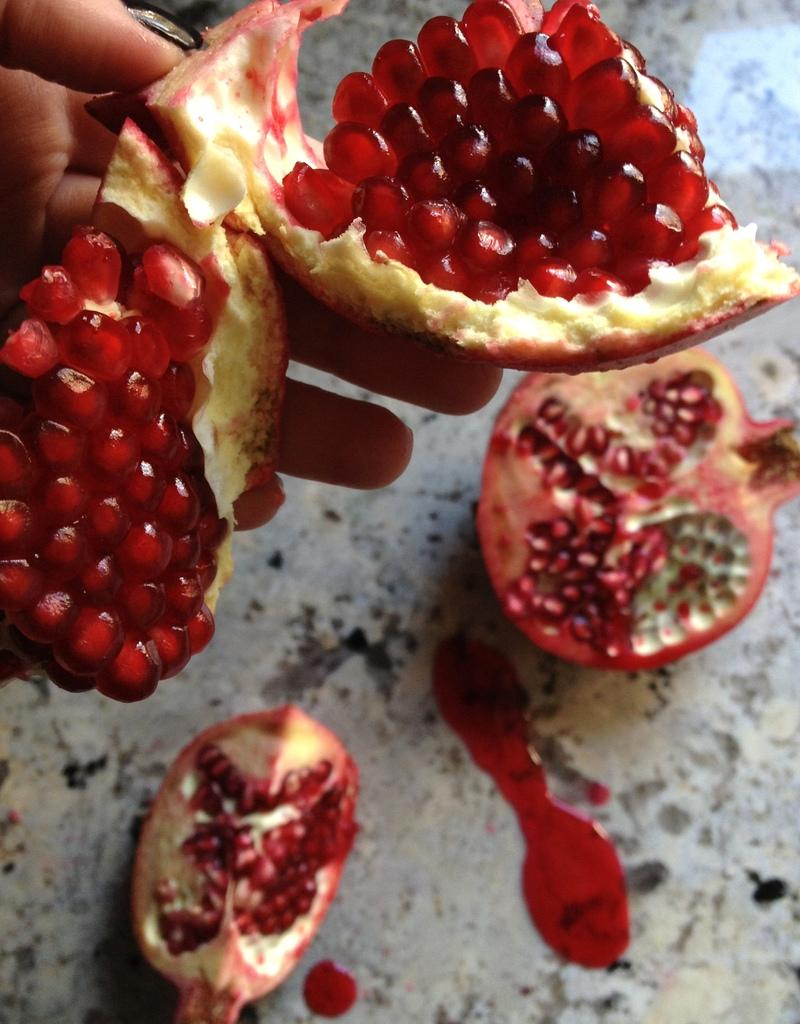What fruit is the main subject of the picture? There is a pomegranate in the picture. How many pieces of the pomegranate are placed on the floor? Two pieces of the pomegranate are placed on the floor. What is the color of the pomegranate? The pomegranate is in red color. How is one piece of the pomegranate being held? One piece of the pomegranate is held in a human hand. How many geese are flying over the pomegranate in the image? There are no geese present in the image; it only features a pomegranate and a human hand holding a piece of it. What thrilling activity is happening with the pomegranate in the image? There is no thrilling activity depicted in the image; it simply shows a pomegranate and its pieces. 